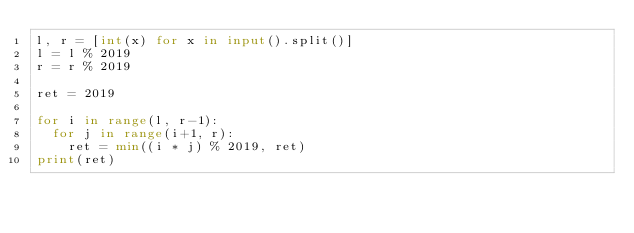<code> <loc_0><loc_0><loc_500><loc_500><_Python_>l, r = [int(x) for x in input().split()]
l = l % 2019
r = r % 2019

ret = 2019

for i in range(l, r-1):
  for j in range(i+1, r):
    ret = min((i * j) % 2019, ret)
print(ret)
</code> 